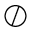Convert formula to latex. <formula><loc_0><loc_0><loc_500><loc_500>\oslash</formula> 